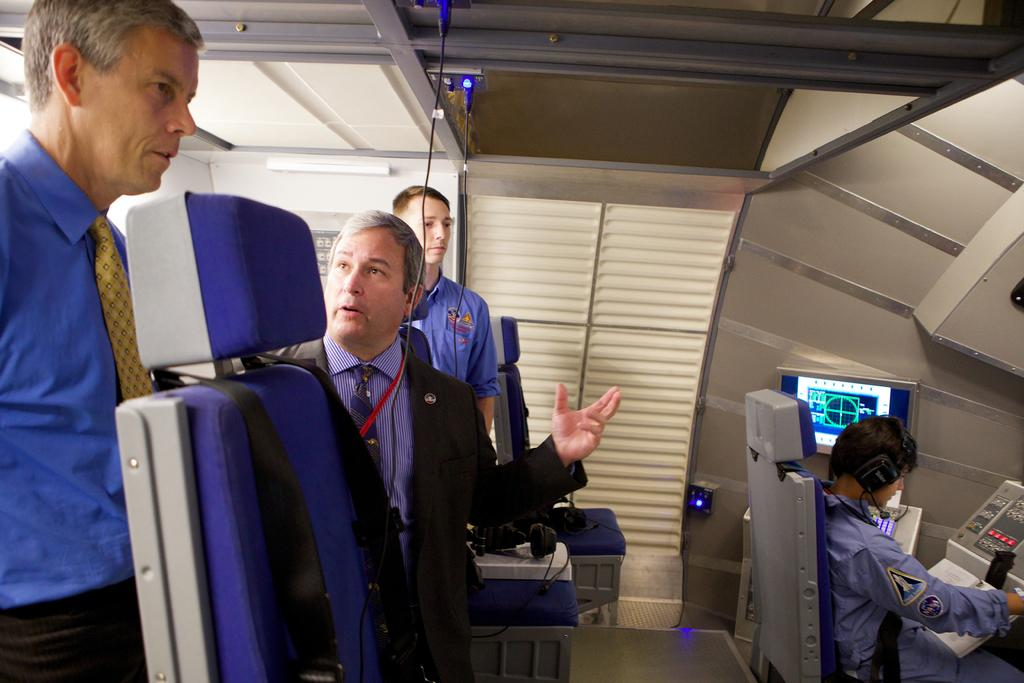How many people are present in the image? There are 4 people in the image. Where are the people located? The people are inside a cabin. What type of furniture is present in the cabin? There are chairs in the cabin. What type of equipment can be seen in the cabin? There are computer systems in the cabin. Can you see a duck fighting with someone in the image? No, there is no duck or any fighting depicted in the image. 